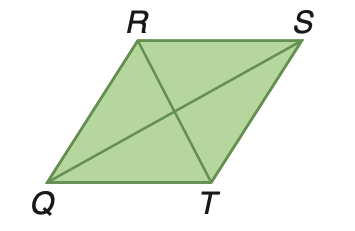Answer the mathemtical geometry problem and directly provide the correct option letter.
Question: Rhombus Q R S T has an area of 137.9 square meters. If R T is 12.2 meters, find Q S.
Choices: A: 11.3 B: 22.4 C: 22.6 D: 25.6 C 